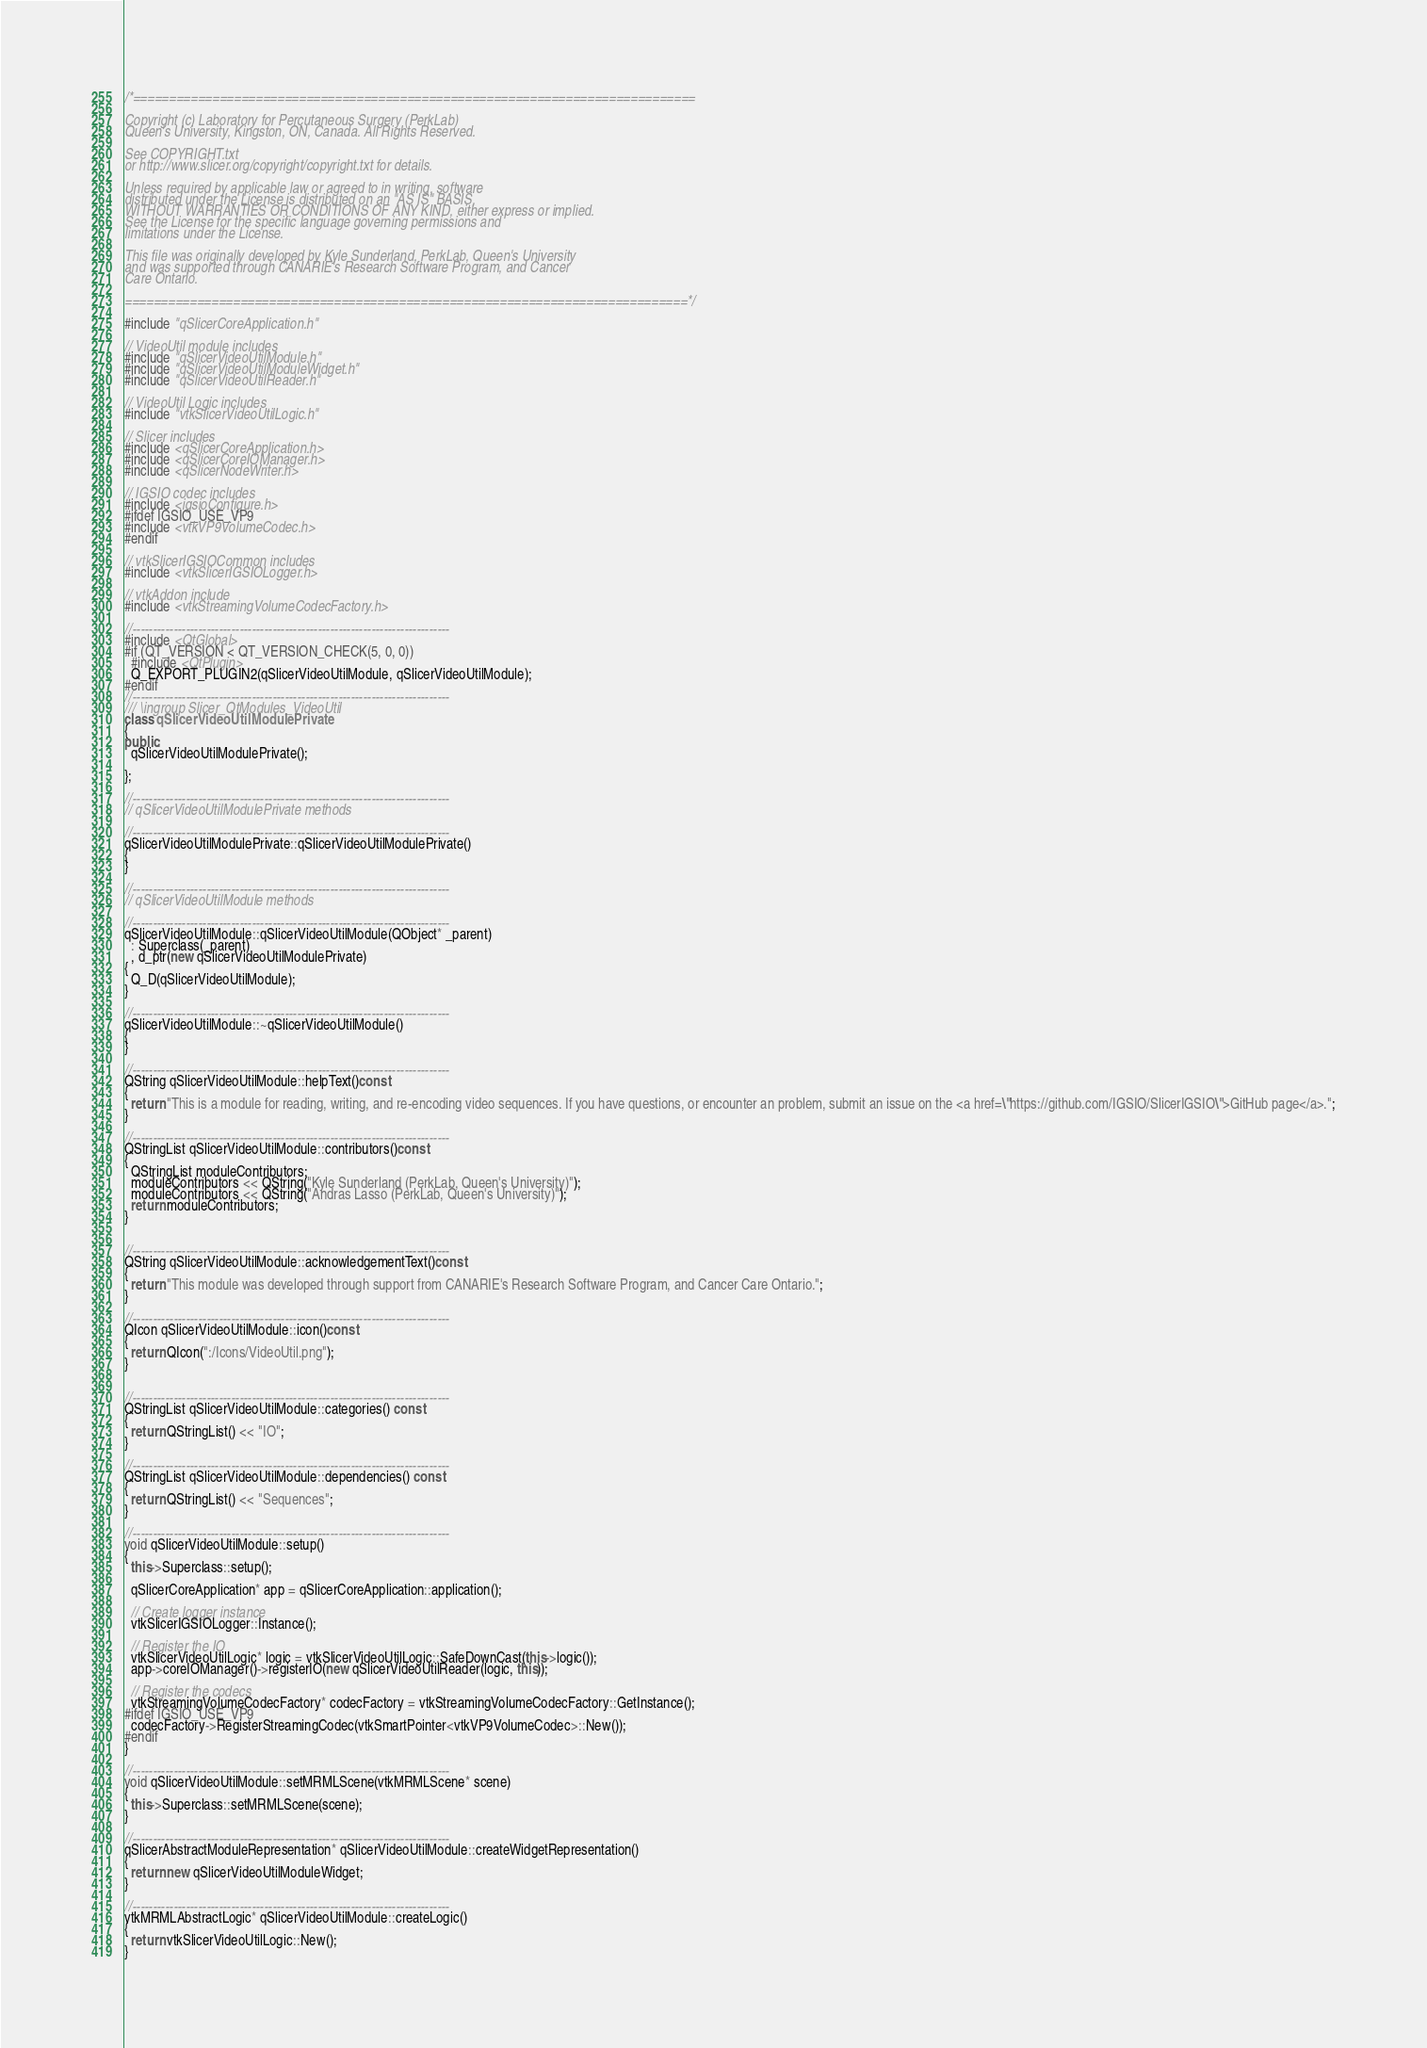Convert code to text. <code><loc_0><loc_0><loc_500><loc_500><_C++_>/*==============================================================================

Copyright (c) Laboratory for Percutaneous Surgery (PerkLab)
Queen's University, Kingston, ON, Canada. All Rights Reserved.

See COPYRIGHT.txt
or http://www.slicer.org/copyright/copyright.txt for details.

Unless required by applicable law or agreed to in writing, software
distributed under the License is distributed on an "AS IS" BASIS,
WITHOUT WARRANTIES OR CONDITIONS OF ANY KIND, either express or implied.
See the License for the specific language governing permissions and
limitations under the License.

This file was originally developed by Kyle Sunderland, PerkLab, Queen's University
and was supported through CANARIE's Research Software Program, and Cancer
Care Ontario.

==============================================================================*/

#include "qSlicerCoreApplication.h"

// VideoUtil module includes
#include "qSlicerVideoUtilModule.h"
#include "qSlicerVideoUtilModuleWidget.h"
#include "qSlicerVideoUtilReader.h"

// VideoUtil Logic includes
#include "vtkSlicerVideoUtilLogic.h"

// Slicer includes
#include <qSlicerCoreApplication.h>
#include <qSlicerCoreIOManager.h>
#include <qSlicerNodeWriter.h>

// IGSIO codec includes
#include <igsioConfigure.h>
#ifdef IGSIO_USE_VP9
#include <vtkVP9VolumeCodec.h>
#endif

// vtkSlicerIGSIOCommon includes
#include <vtkSlicerIGSIOLogger.h>

// vtkAddon include
#include <vtkStreamingVolumeCodecFactory.h>

//-----------------------------------------------------------------------------
#include <QtGlobal>
#if (QT_VERSION < QT_VERSION_CHECK(5, 0, 0))
  #include <QtPlugin>
  Q_EXPORT_PLUGIN2(qSlicerVideoUtilModule, qSlicerVideoUtilModule);
#endif
//-----------------------------------------------------------------------------
/// \ingroup Slicer_QtModules_VideoUtil
class qSlicerVideoUtilModulePrivate
{
public:
  qSlicerVideoUtilModulePrivate();

};

//-----------------------------------------------------------------------------
// qSlicerVideoUtilModulePrivate methods

//-----------------------------------------------------------------------------
qSlicerVideoUtilModulePrivate::qSlicerVideoUtilModulePrivate()
{
}

//-----------------------------------------------------------------------------
// qSlicerVideoUtilModule methods

//-----------------------------------------------------------------------------
qSlicerVideoUtilModule::qSlicerVideoUtilModule(QObject* _parent)
  : Superclass(_parent)
  , d_ptr(new qSlicerVideoUtilModulePrivate)
{
  Q_D(qSlicerVideoUtilModule);
}

//-----------------------------------------------------------------------------
qSlicerVideoUtilModule::~qSlicerVideoUtilModule()
{
}

//-----------------------------------------------------------------------------
QString qSlicerVideoUtilModule::helpText()const
{
  return "This is a module for reading, writing, and re-encoding video sequences. If you have questions, or encounter an problem, submit an issue on the <a href=\"https://github.com/IGSIO/SlicerIGSIO\">GitHub page</a>.";
}

//-----------------------------------------------------------------------------
QStringList qSlicerVideoUtilModule::contributors()const
{
  QStringList moduleContributors;
  moduleContributors << QString("Kyle Sunderland (PerkLab, Queen's University)");
  moduleContributors << QString("Andras Lasso (PerkLab, Queen's University)");
  return moduleContributors;
}


//-----------------------------------------------------------------------------
QString qSlicerVideoUtilModule::acknowledgementText()const
{
  return "This module was developed through support from CANARIE's Research Software Program, and Cancer Care Ontario.";
}

//-----------------------------------------------------------------------------
QIcon qSlicerVideoUtilModule::icon()const
{
  return QIcon(":/Icons/VideoUtil.png");
}


//-----------------------------------------------------------------------------
QStringList qSlicerVideoUtilModule::categories() const
{
  return QStringList() << "IO";
}

//-----------------------------------------------------------------------------
QStringList qSlicerVideoUtilModule::dependencies() const
{
  return QStringList() << "Sequences";
}

//-----------------------------------------------------------------------------
void qSlicerVideoUtilModule::setup()
{
  this->Superclass::setup();

  qSlicerCoreApplication* app = qSlicerCoreApplication::application();

  // Create logger instance
  vtkSlicerIGSIOLogger::Instance();

  // Register the IO
  vtkSlicerVideoUtilLogic* logic = vtkSlicerVideoUtilLogic::SafeDownCast(this->logic());
  app->coreIOManager()->registerIO(new qSlicerVideoUtilReader(logic, this));

  // Register the codecs
  vtkStreamingVolumeCodecFactory* codecFactory = vtkStreamingVolumeCodecFactory::GetInstance();
#ifdef IGSIO_USE_VP9
  codecFactory->RegisterStreamingCodec(vtkSmartPointer<vtkVP9VolumeCodec>::New());
#endif
}

//-----------------------------------------------------------------------------
void qSlicerVideoUtilModule::setMRMLScene(vtkMRMLScene* scene)
{
  this->Superclass::setMRMLScene(scene);
}

//-----------------------------------------------------------------------------
qSlicerAbstractModuleRepresentation* qSlicerVideoUtilModule::createWidgetRepresentation()
{
  return new qSlicerVideoUtilModuleWidget;
}

//-----------------------------------------------------------------------------
vtkMRMLAbstractLogic* qSlicerVideoUtilModule::createLogic()
{
  return vtkSlicerVideoUtilLogic::New();
}
</code> 